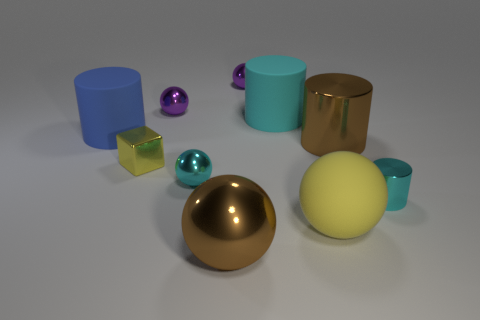Subtract all cylinders. How many objects are left? 6 Add 3 yellow balls. How many yellow balls are left? 4 Add 9 yellow cubes. How many yellow cubes exist? 10 Subtract all cyan cylinders. How many cylinders are left? 2 Subtract all yellow balls. How many balls are left? 4 Subtract 2 cyan cylinders. How many objects are left? 8 Subtract 4 spheres. How many spheres are left? 1 Subtract all gray cylinders. Subtract all red spheres. How many cylinders are left? 4 Subtract all red blocks. How many purple balls are left? 2 Subtract all big yellow shiny blocks. Subtract all large yellow spheres. How many objects are left? 9 